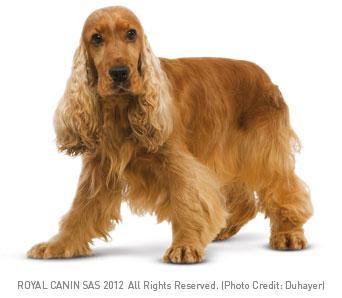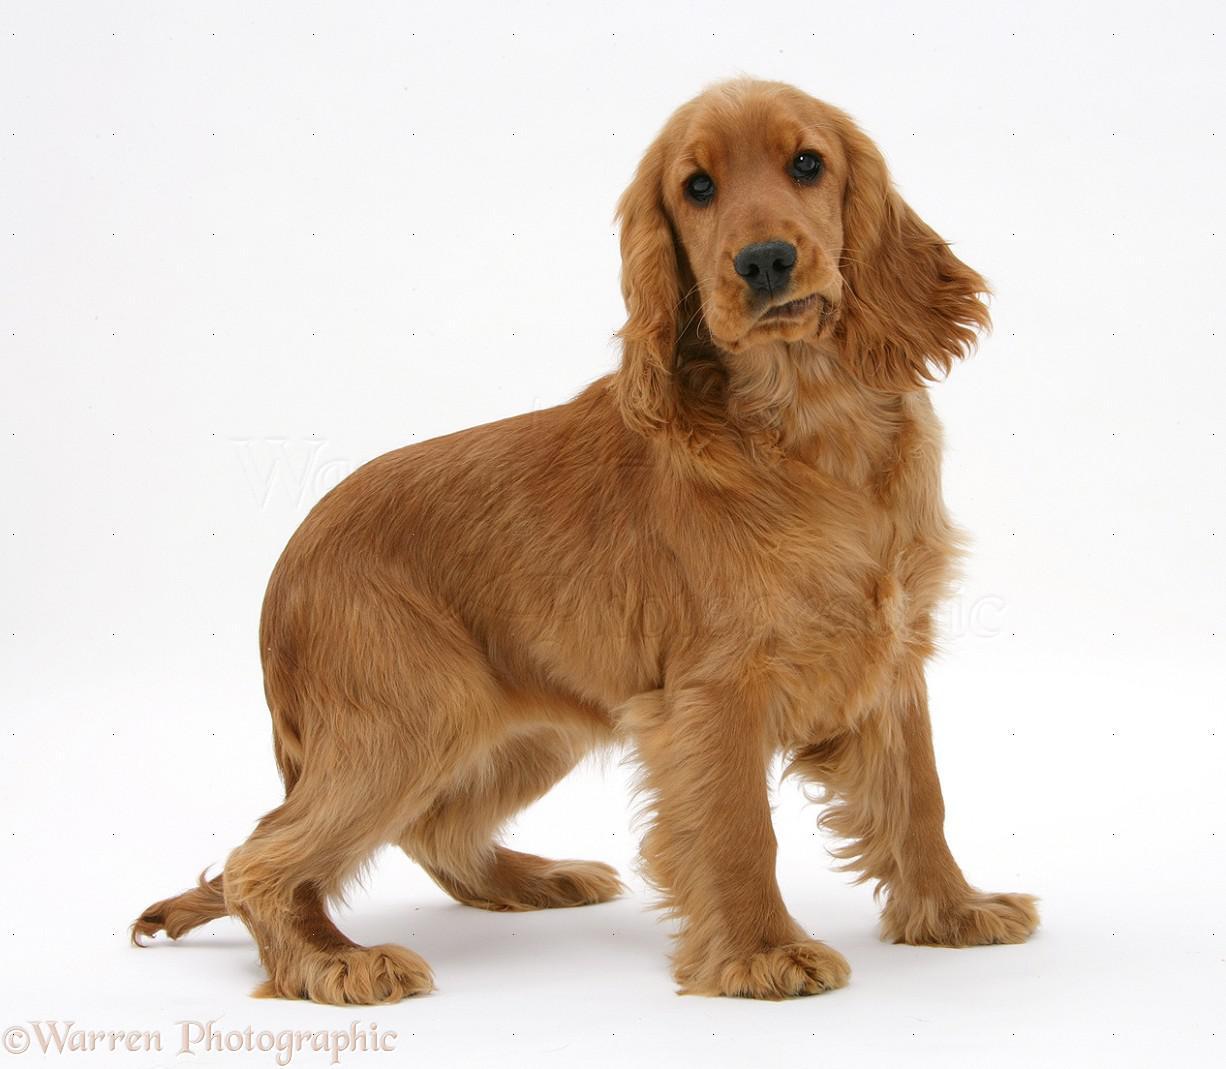The first image is the image on the left, the second image is the image on the right. Examine the images to the left and right. Is the description "The dog in the image on the right is sitting down" accurate? Answer yes or no. No. The first image is the image on the left, the second image is the image on the right. For the images shown, is this caption "A dog has its tongue sticking out." true? Answer yes or no. No. 